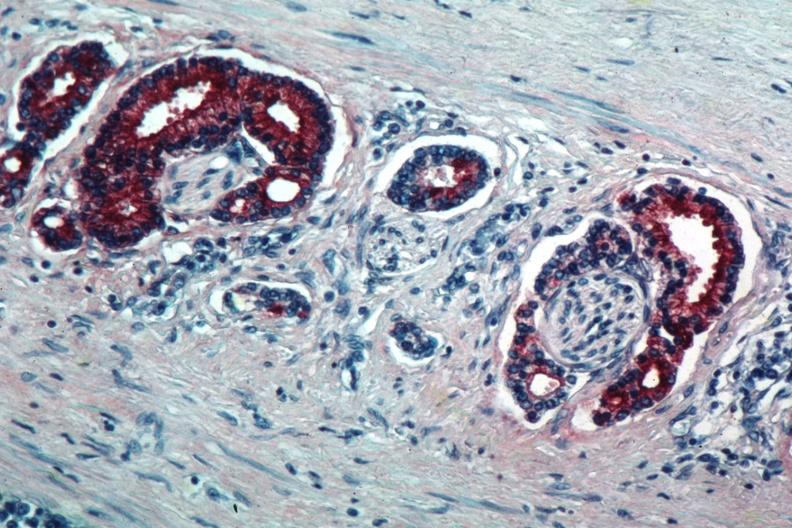what is present?
Answer the question using a single word or phrase. Adenocarcinoma 